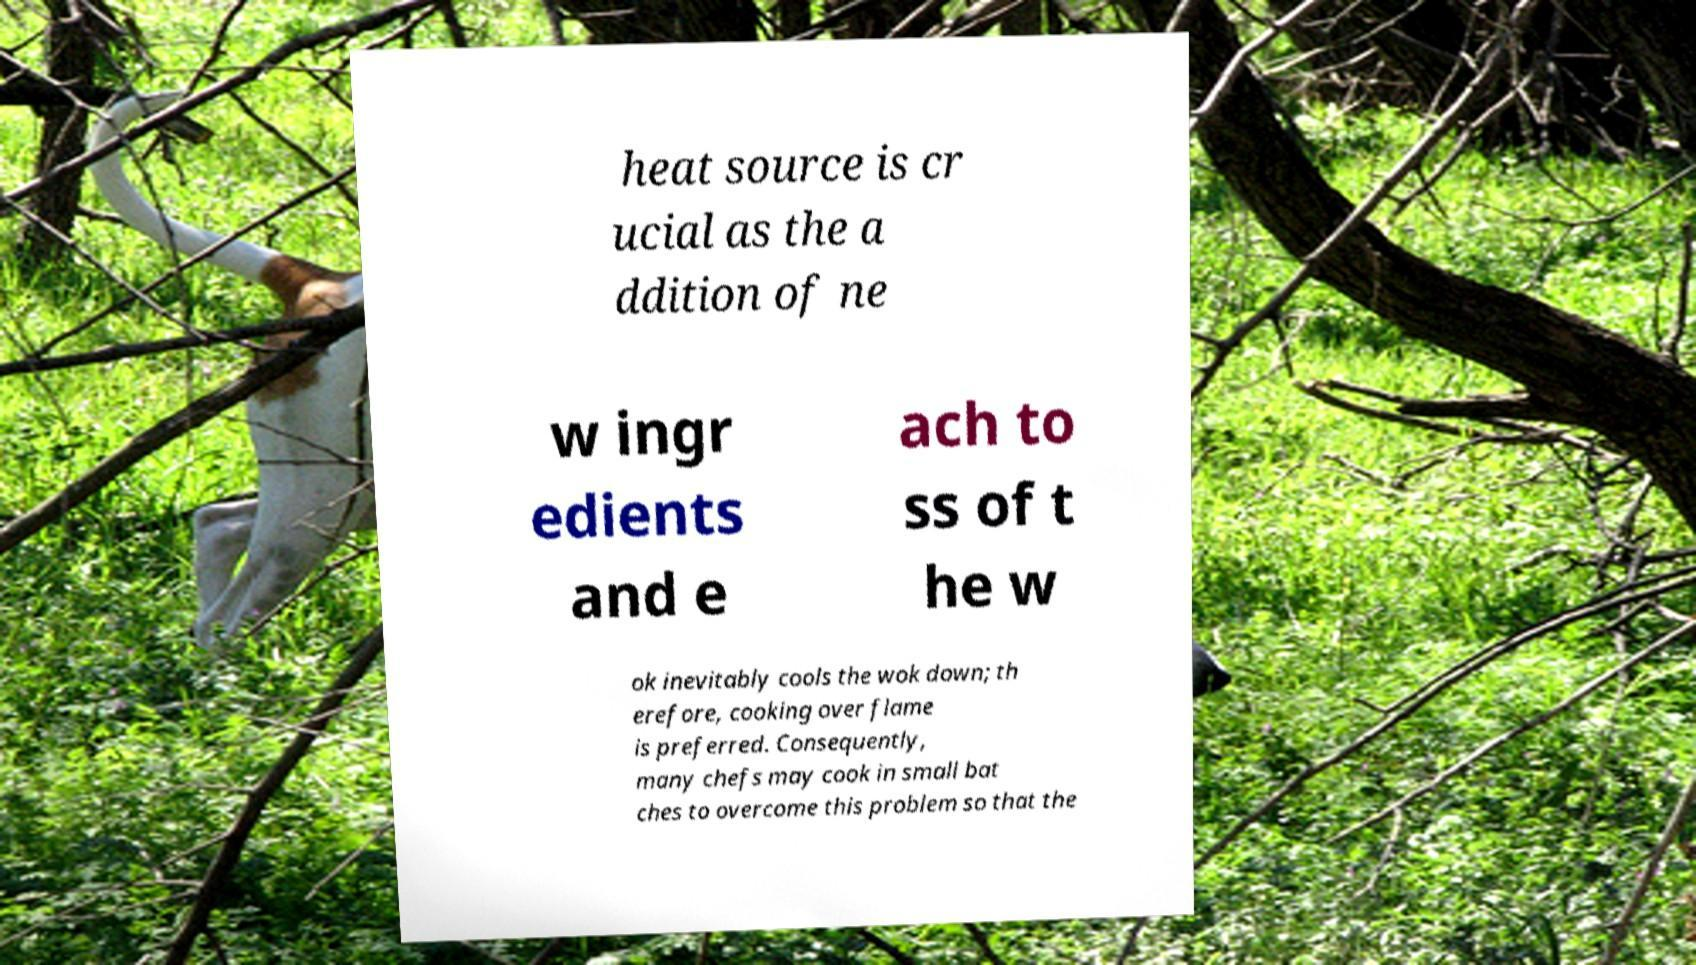Please read and relay the text visible in this image. What does it say? heat source is cr ucial as the a ddition of ne w ingr edients and e ach to ss of t he w ok inevitably cools the wok down; th erefore, cooking over flame is preferred. Consequently, many chefs may cook in small bat ches to overcome this problem so that the 